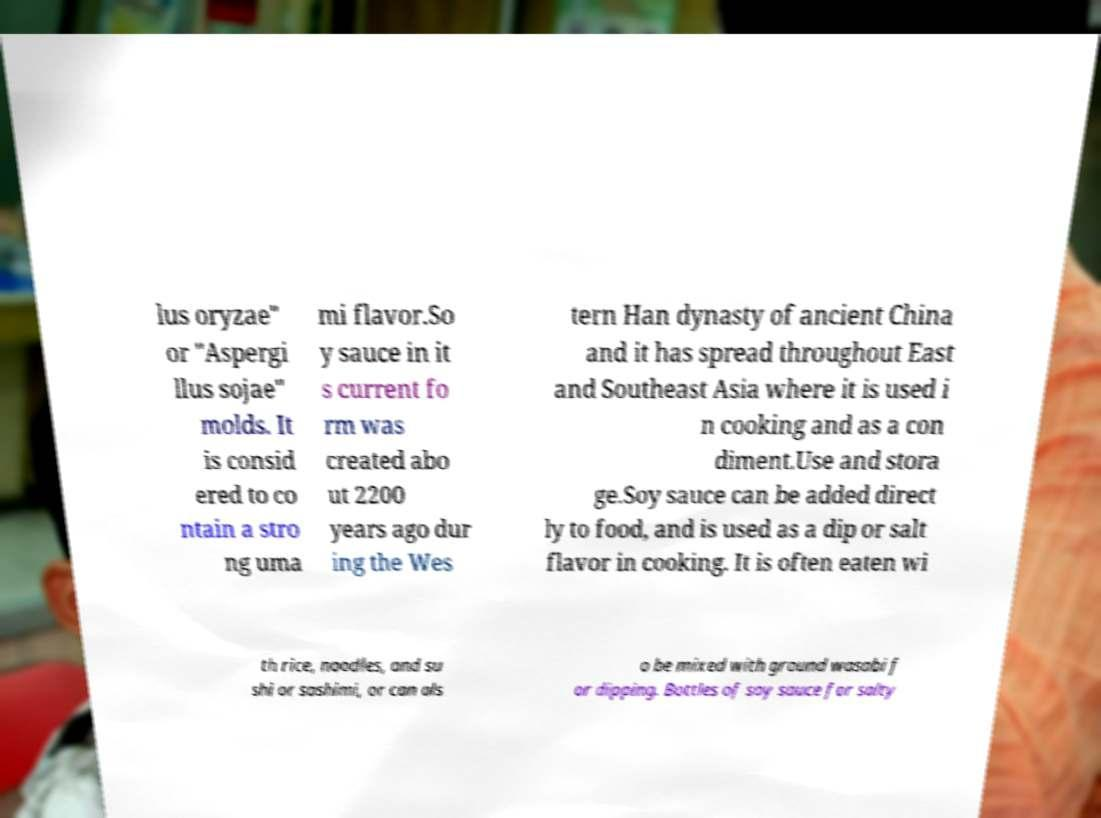What messages or text are displayed in this image? I need them in a readable, typed format. lus oryzae" or "Aspergi llus sojae" molds. It is consid ered to co ntain a stro ng uma mi flavor.So y sauce in it s current fo rm was created abo ut 2200 years ago dur ing the Wes tern Han dynasty of ancient China and it has spread throughout East and Southeast Asia where it is used i n cooking and as a con diment.Use and stora ge.Soy sauce can be added direct ly to food, and is used as a dip or salt flavor in cooking. It is often eaten wi th rice, noodles, and su shi or sashimi, or can als o be mixed with ground wasabi f or dipping. Bottles of soy sauce for salty 